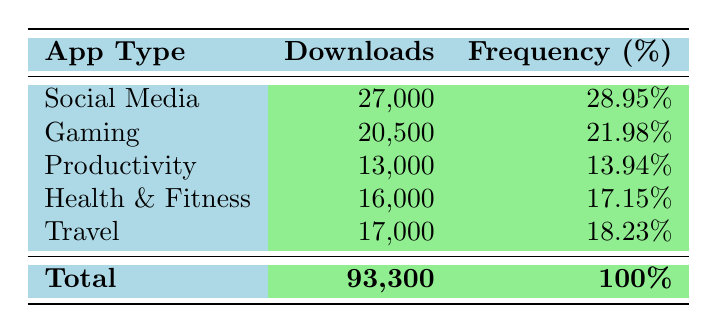What is the total number of downloads for Social Media apps? The downloads for Social Media apps are totalled from Instagram (12,000) and Facebook (15,000). Summing these values gives 12,000 + 15,000 = 27,000.
Answer: 27,000 Which app type has the highest number of downloads? Comparing the total downloads across all app types, Social Media has 27,000, Gaming has 20,500, Productivity has 13,000, Health & Fitness has 16,000, and Travel has 17,000. Social Media has the highest value.
Answer: Social Media What percentage of total downloads does Gaming represent? The total downloads amount to 93,300, and Gaming has 20,500 downloads. To find the percentage, divide Gaming downloads by the total downloads and multiply by 100: (20,500 / 93,300) * 100 ≈ 21.98%.
Answer: 21.98% True or False: The total number of downloads for Health & Fitness apps is greater than that for Productivity apps. Health & Fitness has 16,000 downloads while Productivity has 13,000. Since 16,000 is greater than 13,000, the statement is true.
Answer: True What is the difference in downloads between the highest and lowest app type? The highest app type is Social Media with 27,000 downloads, and the lowest is Productivity with 13,000 downloads. The difference can be calculated as 27,000 - 13,000 = 14,000.
Answer: 14,000 What is the average number of downloads among all app types? To find the average, sum all downloads: 27,000 + 20,500 + 13,000 + 16,000 + 17,000 = 93,500, then divide by the number of app types (5): 93,500 / 5 = 18,700.
Answer: 18,700 Which app type contributed the least to the overall app downloads? By comparing the total downloads: Social Media (27,000), Gaming (20,500), Productivity (13,000), Health & Fitness (16,000), and Travel (17,000), Productivity has the smallest total at 13,000.
Answer: Productivity What is the total percentage contribution of Health & Fitness and Travel app types combined? Adding the percentages: Health & Fitness is 17.15% and Travel is 18.23%. The combined percentage is 17.15 + 18.23 = 35.38%.
Answer: 35.38% Which app type has a total download figure closest to 20,000? Social Media has 27,000, Gaming has 20,500, Productivity has 13,000, Health & Fitness has 16,000, and Travel has 17,000. Gaming's total of 20,500 is closest to 20,000.
Answer: Gaming 